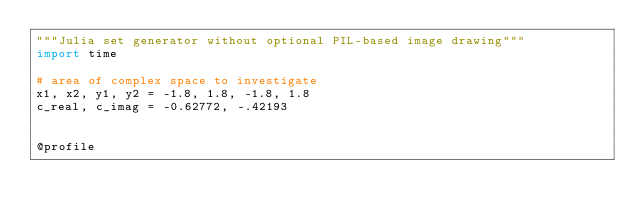<code> <loc_0><loc_0><loc_500><loc_500><_Python_>"""Julia set generator without optional PIL-based image drawing"""
import time

# area of complex space to investigate
x1, x2, y1, y2 = -1.8, 1.8, -1.8, 1.8
c_real, c_imag = -0.62772, -.42193


@profile</code> 